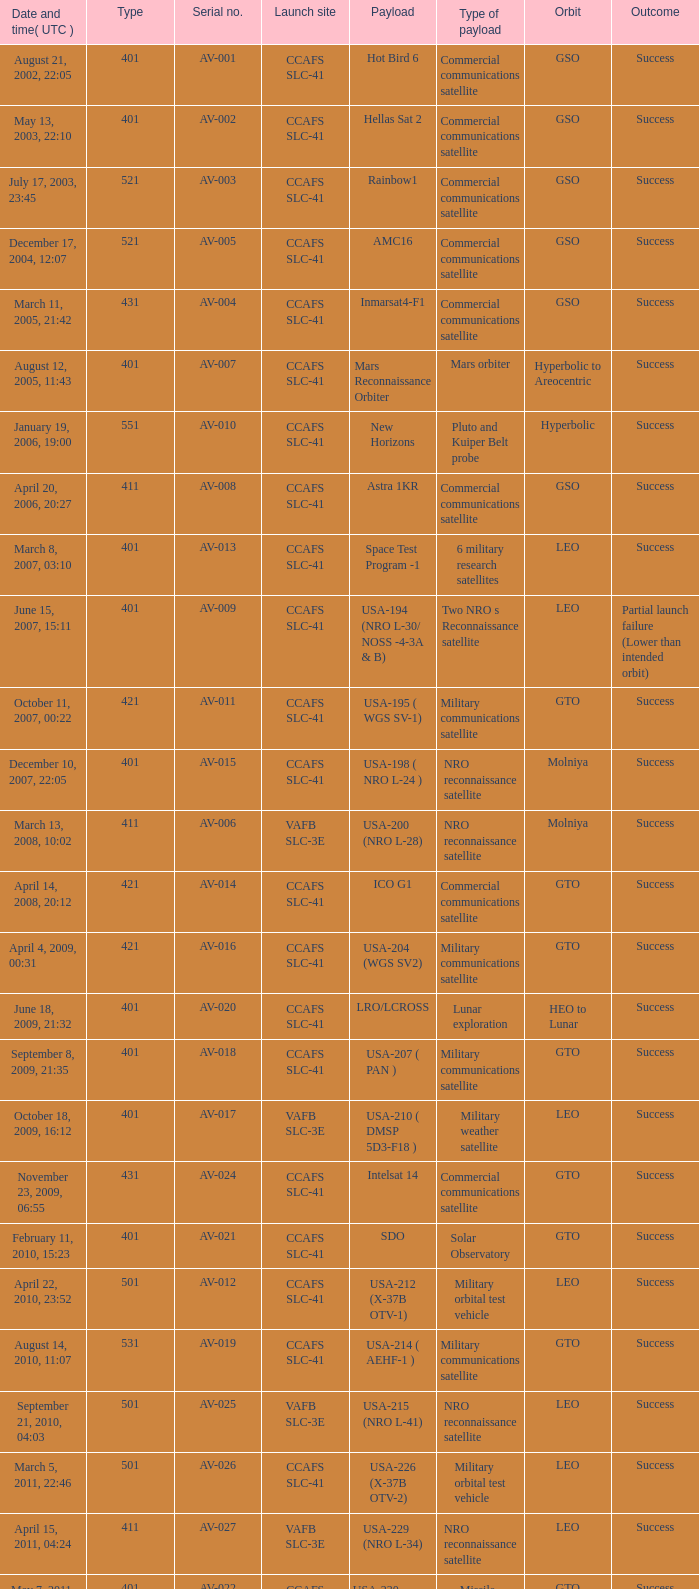For the van allen belts exploration payload, what is the identification number? AV-032. 